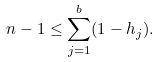Convert formula to latex. <formula><loc_0><loc_0><loc_500><loc_500>n - 1 \leq \sum _ { j = 1 } ^ { b } ( 1 - h _ { j } ) .</formula> 